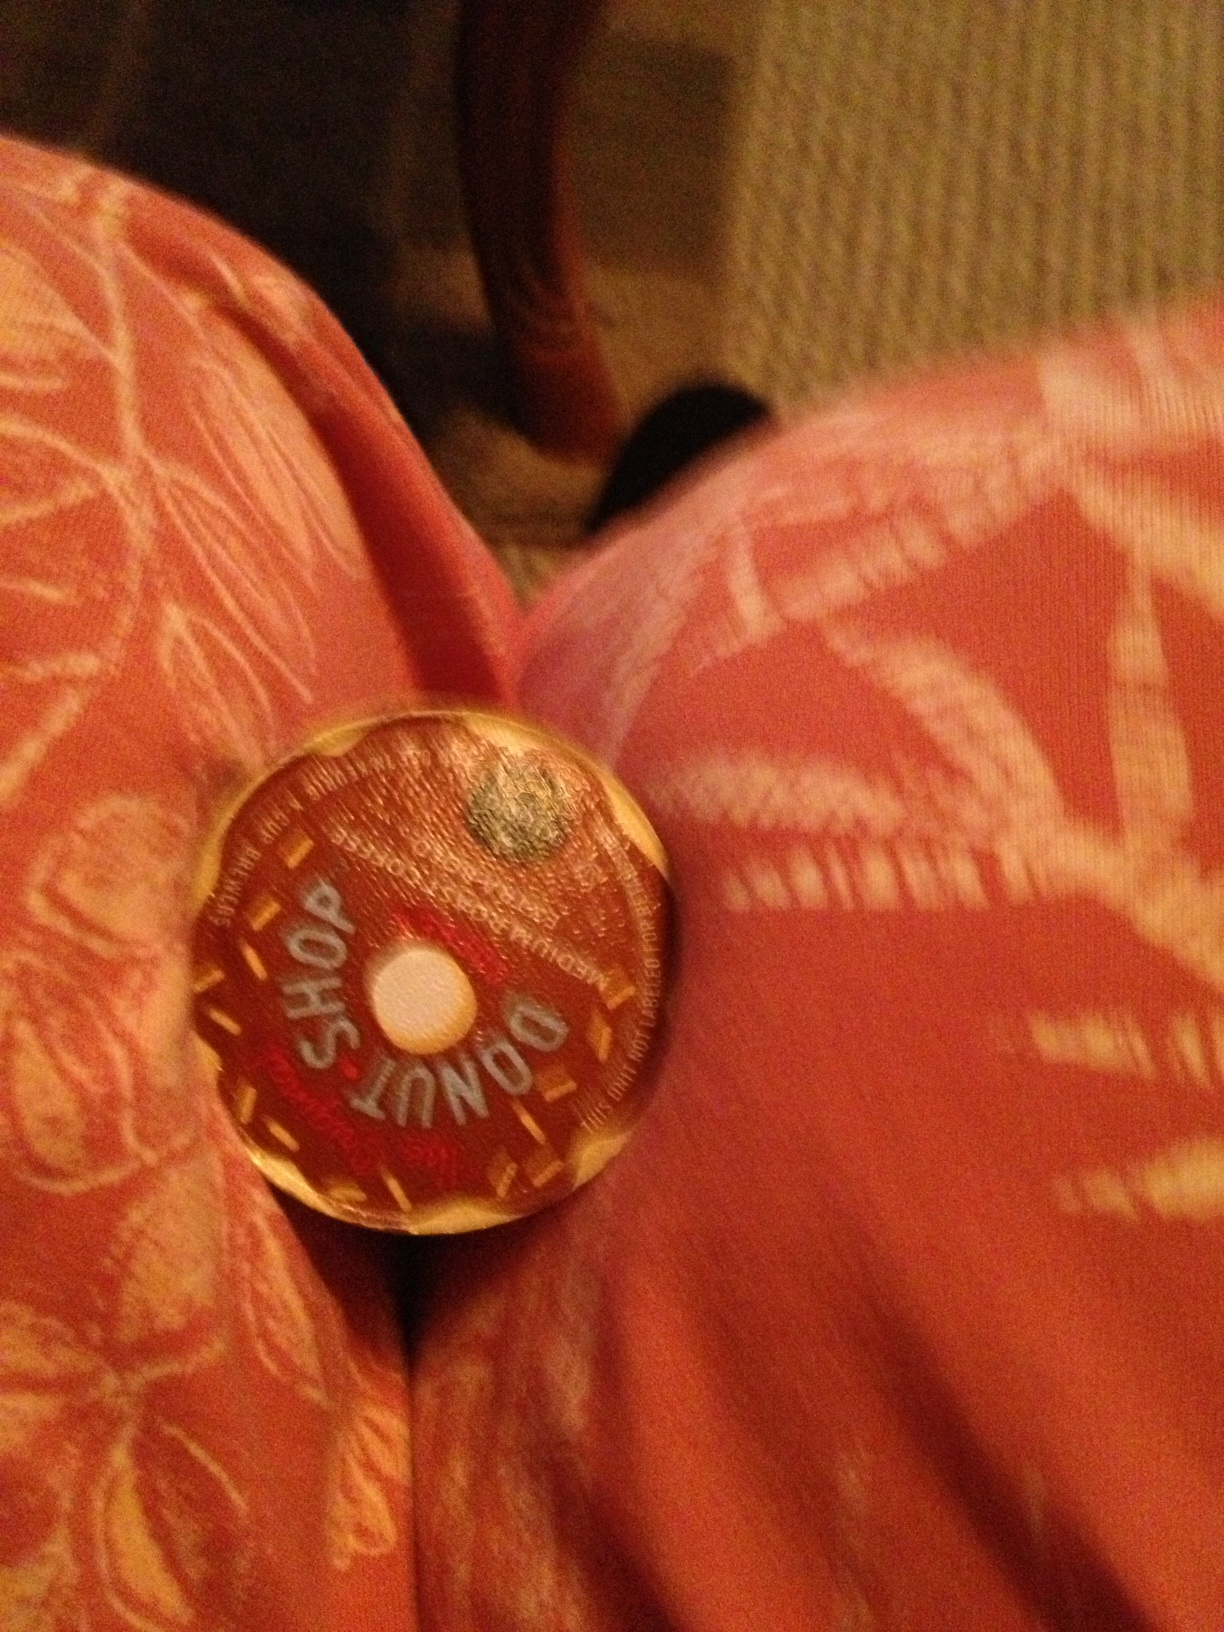What kind of coffee is this? This appears to be a coffee pod from a brand called 'Donut Shop', which is known for producing a range of coffee flavors typically enjoyed for their classic, sweet, donut-like taste. 